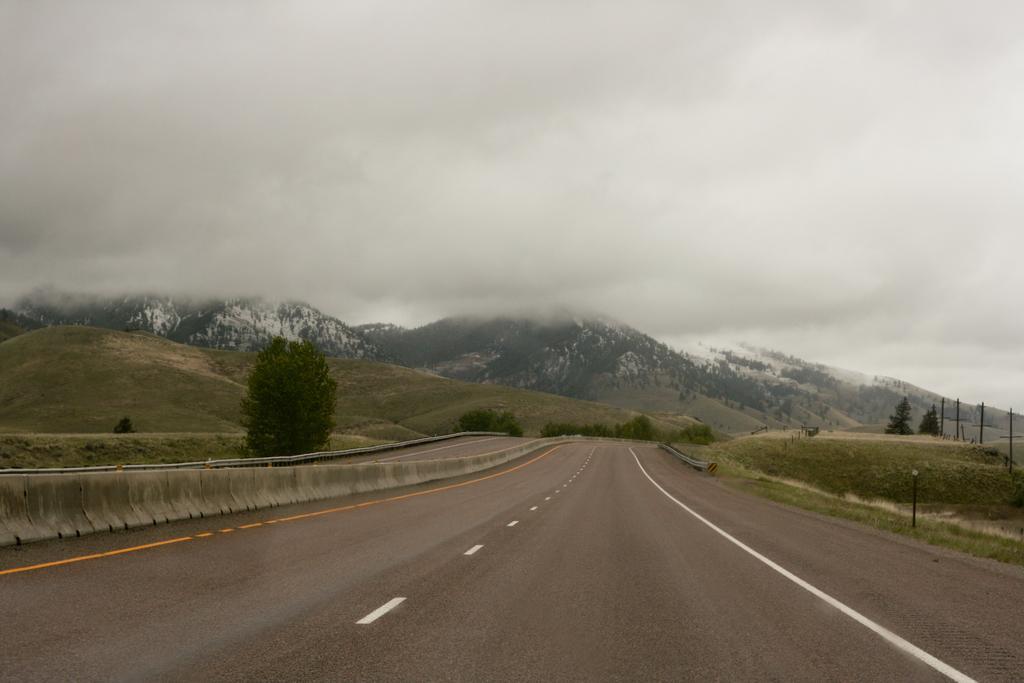Could you give a brief overview of what you see in this image? In this picture we can see the hills, trees, grass, railing, poles. At the bottom of the image we can see the road. At the top of the image we can see the clouds are present in the sky. 